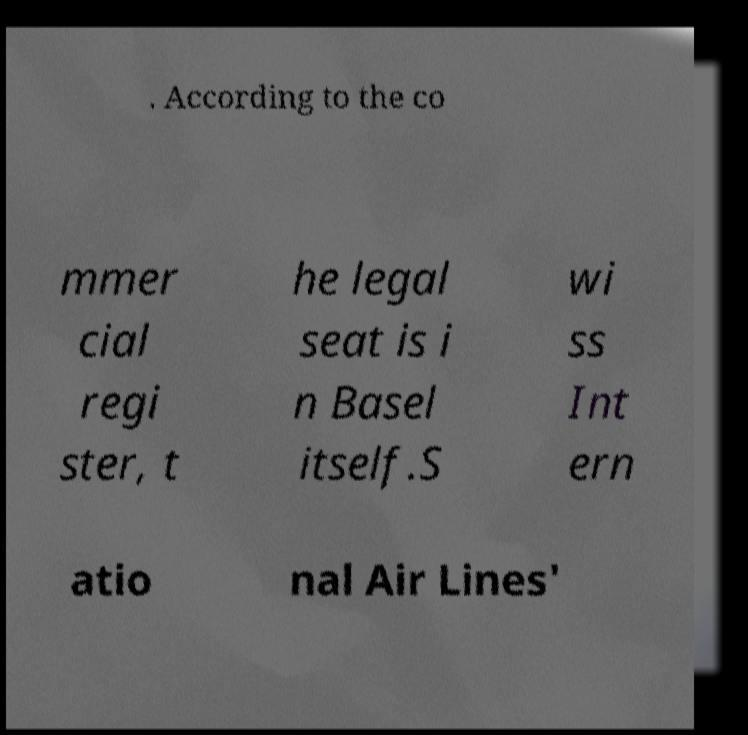Please identify and transcribe the text found in this image. . According to the co mmer cial regi ster, t he legal seat is i n Basel itself.S wi ss Int ern atio nal Air Lines' 